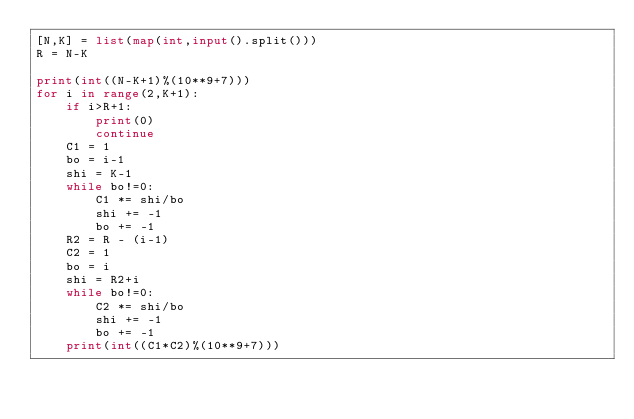<code> <loc_0><loc_0><loc_500><loc_500><_Python_>[N,K] = list(map(int,input().split()))
R = N-K

print(int((N-K+1)%(10**9+7)))
for i in range(2,K+1):
    if i>R+1:
        print(0)
        continue
    C1 = 1
    bo = i-1
    shi = K-1
    while bo!=0:
        C1 *= shi/bo
        shi += -1
        bo += -1
    R2 = R - (i-1)
    C2 = 1
    bo = i
    shi = R2+i
    while bo!=0:
        C2 *= shi/bo
        shi += -1
        bo += -1
    print(int((C1*C2)%(10**9+7)))</code> 